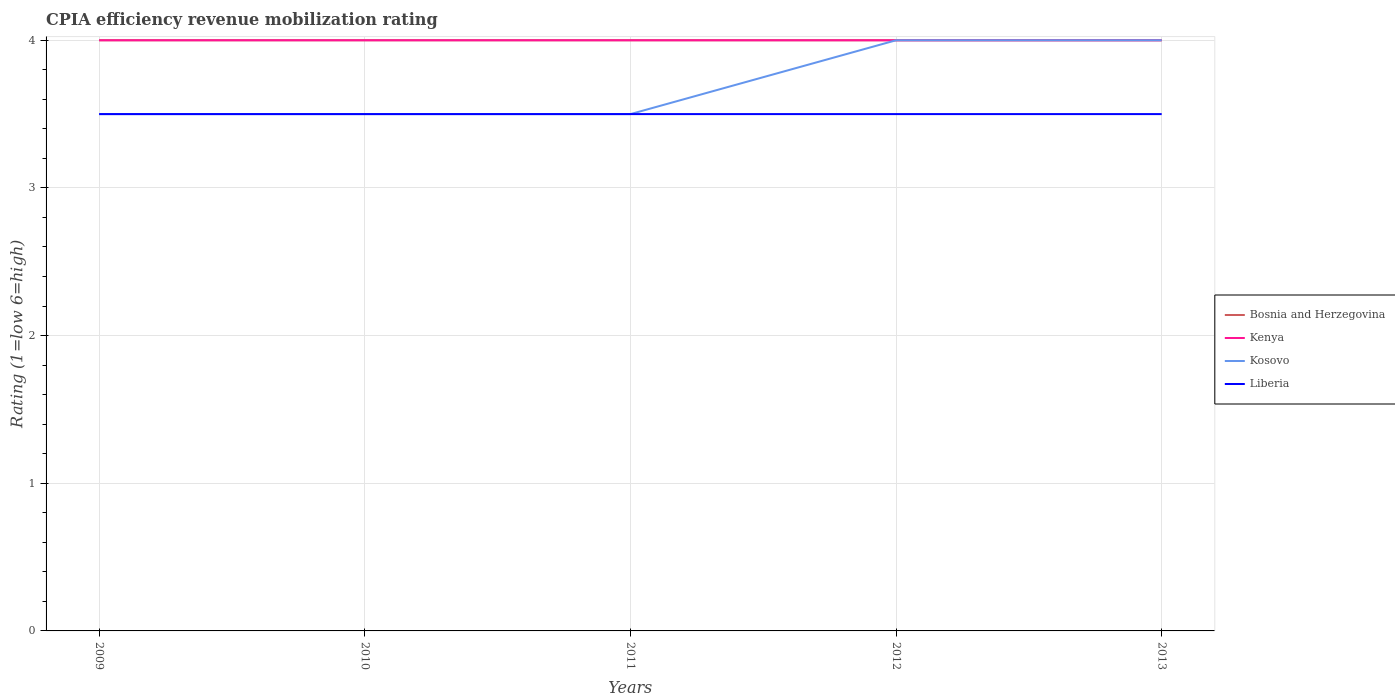How many different coloured lines are there?
Your response must be concise. 4. Is the number of lines equal to the number of legend labels?
Offer a very short reply. Yes. Across all years, what is the maximum CPIA rating in Kenya?
Provide a short and direct response. 4. In which year was the CPIA rating in Kosovo maximum?
Your answer should be compact. 2009. What is the total CPIA rating in Bosnia and Herzegovina in the graph?
Offer a terse response. 0. What is the difference between the highest and the lowest CPIA rating in Liberia?
Give a very brief answer. 0. Is the CPIA rating in Kenya strictly greater than the CPIA rating in Liberia over the years?
Make the answer very short. No. What is the difference between two consecutive major ticks on the Y-axis?
Offer a very short reply. 1. Are the values on the major ticks of Y-axis written in scientific E-notation?
Give a very brief answer. No. What is the title of the graph?
Provide a succinct answer. CPIA efficiency revenue mobilization rating. Does "Fragile and conflict affected situations" appear as one of the legend labels in the graph?
Provide a short and direct response. No. What is the label or title of the X-axis?
Offer a terse response. Years. What is the label or title of the Y-axis?
Your answer should be very brief. Rating (1=low 6=high). What is the Rating (1=low 6=high) of Kosovo in 2009?
Give a very brief answer. 3.5. What is the Rating (1=low 6=high) of Liberia in 2009?
Provide a short and direct response. 3.5. What is the Rating (1=low 6=high) of Bosnia and Herzegovina in 2010?
Your answer should be compact. 4. What is the Rating (1=low 6=high) of Liberia in 2010?
Provide a succinct answer. 3.5. What is the Rating (1=low 6=high) in Bosnia and Herzegovina in 2011?
Make the answer very short. 4. What is the Rating (1=low 6=high) in Liberia in 2011?
Your answer should be compact. 3.5. What is the Rating (1=low 6=high) of Bosnia and Herzegovina in 2012?
Offer a terse response. 4. What is the Rating (1=low 6=high) of Kenya in 2012?
Provide a succinct answer. 4. What is the Rating (1=low 6=high) of Liberia in 2012?
Your response must be concise. 3.5. What is the Rating (1=low 6=high) in Kosovo in 2013?
Give a very brief answer. 4. Across all years, what is the maximum Rating (1=low 6=high) of Kenya?
Give a very brief answer. 4. Across all years, what is the maximum Rating (1=low 6=high) of Liberia?
Your response must be concise. 3.5. Across all years, what is the minimum Rating (1=low 6=high) in Kenya?
Ensure brevity in your answer.  4. What is the total Rating (1=low 6=high) in Bosnia and Herzegovina in the graph?
Ensure brevity in your answer.  20. What is the total Rating (1=low 6=high) in Kenya in the graph?
Ensure brevity in your answer.  20. What is the total Rating (1=low 6=high) of Kosovo in the graph?
Offer a very short reply. 18.5. What is the difference between the Rating (1=low 6=high) of Kenya in 2009 and that in 2010?
Make the answer very short. 0. What is the difference between the Rating (1=low 6=high) in Kosovo in 2009 and that in 2010?
Make the answer very short. 0. What is the difference between the Rating (1=low 6=high) of Liberia in 2009 and that in 2010?
Your answer should be compact. 0. What is the difference between the Rating (1=low 6=high) of Kenya in 2009 and that in 2011?
Provide a short and direct response. 0. What is the difference between the Rating (1=low 6=high) of Liberia in 2009 and that in 2011?
Your answer should be compact. 0. What is the difference between the Rating (1=low 6=high) in Bosnia and Herzegovina in 2009 and that in 2012?
Provide a succinct answer. 0. What is the difference between the Rating (1=low 6=high) of Kosovo in 2009 and that in 2012?
Your response must be concise. -0.5. What is the difference between the Rating (1=low 6=high) in Liberia in 2009 and that in 2012?
Your answer should be compact. 0. What is the difference between the Rating (1=low 6=high) in Bosnia and Herzegovina in 2009 and that in 2013?
Your answer should be very brief. 0. What is the difference between the Rating (1=low 6=high) of Kosovo in 2009 and that in 2013?
Ensure brevity in your answer.  -0.5. What is the difference between the Rating (1=low 6=high) in Liberia in 2009 and that in 2013?
Ensure brevity in your answer.  0. What is the difference between the Rating (1=low 6=high) of Bosnia and Herzegovina in 2010 and that in 2011?
Give a very brief answer. 0. What is the difference between the Rating (1=low 6=high) of Kenya in 2010 and that in 2011?
Provide a short and direct response. 0. What is the difference between the Rating (1=low 6=high) in Kosovo in 2010 and that in 2011?
Your answer should be very brief. 0. What is the difference between the Rating (1=low 6=high) of Liberia in 2010 and that in 2011?
Give a very brief answer. 0. What is the difference between the Rating (1=low 6=high) in Liberia in 2010 and that in 2012?
Give a very brief answer. 0. What is the difference between the Rating (1=low 6=high) in Kosovo in 2010 and that in 2013?
Keep it short and to the point. -0.5. What is the difference between the Rating (1=low 6=high) of Bosnia and Herzegovina in 2011 and that in 2012?
Your response must be concise. 0. What is the difference between the Rating (1=low 6=high) of Liberia in 2011 and that in 2012?
Keep it short and to the point. 0. What is the difference between the Rating (1=low 6=high) in Bosnia and Herzegovina in 2011 and that in 2013?
Give a very brief answer. 0. What is the difference between the Rating (1=low 6=high) of Bosnia and Herzegovina in 2012 and that in 2013?
Provide a short and direct response. 0. What is the difference between the Rating (1=low 6=high) in Liberia in 2012 and that in 2013?
Offer a very short reply. 0. What is the difference between the Rating (1=low 6=high) in Bosnia and Herzegovina in 2009 and the Rating (1=low 6=high) in Kosovo in 2010?
Provide a short and direct response. 0.5. What is the difference between the Rating (1=low 6=high) in Kenya in 2009 and the Rating (1=low 6=high) in Kosovo in 2010?
Offer a very short reply. 0.5. What is the difference between the Rating (1=low 6=high) of Kenya in 2009 and the Rating (1=low 6=high) of Kosovo in 2011?
Give a very brief answer. 0.5. What is the difference between the Rating (1=low 6=high) of Kosovo in 2009 and the Rating (1=low 6=high) of Liberia in 2011?
Provide a short and direct response. 0. What is the difference between the Rating (1=low 6=high) of Bosnia and Herzegovina in 2009 and the Rating (1=low 6=high) of Kenya in 2012?
Offer a terse response. 0. What is the difference between the Rating (1=low 6=high) in Kosovo in 2009 and the Rating (1=low 6=high) in Liberia in 2012?
Provide a succinct answer. 0. What is the difference between the Rating (1=low 6=high) in Bosnia and Herzegovina in 2009 and the Rating (1=low 6=high) in Kenya in 2013?
Your answer should be compact. 0. What is the difference between the Rating (1=low 6=high) of Bosnia and Herzegovina in 2009 and the Rating (1=low 6=high) of Liberia in 2013?
Your response must be concise. 0.5. What is the difference between the Rating (1=low 6=high) in Kenya in 2009 and the Rating (1=low 6=high) in Kosovo in 2013?
Keep it short and to the point. 0. What is the difference between the Rating (1=low 6=high) of Kenya in 2010 and the Rating (1=low 6=high) of Kosovo in 2011?
Make the answer very short. 0.5. What is the difference between the Rating (1=low 6=high) of Kosovo in 2010 and the Rating (1=low 6=high) of Liberia in 2011?
Ensure brevity in your answer.  0. What is the difference between the Rating (1=low 6=high) of Kenya in 2010 and the Rating (1=low 6=high) of Kosovo in 2012?
Provide a short and direct response. 0. What is the difference between the Rating (1=low 6=high) in Kosovo in 2010 and the Rating (1=low 6=high) in Liberia in 2012?
Ensure brevity in your answer.  0. What is the difference between the Rating (1=low 6=high) of Bosnia and Herzegovina in 2010 and the Rating (1=low 6=high) of Kenya in 2013?
Your answer should be compact. 0. What is the difference between the Rating (1=low 6=high) of Bosnia and Herzegovina in 2010 and the Rating (1=low 6=high) of Liberia in 2013?
Make the answer very short. 0.5. What is the difference between the Rating (1=low 6=high) in Kenya in 2010 and the Rating (1=low 6=high) in Kosovo in 2013?
Offer a very short reply. 0. What is the difference between the Rating (1=low 6=high) in Bosnia and Herzegovina in 2011 and the Rating (1=low 6=high) in Kenya in 2012?
Your answer should be very brief. 0. What is the difference between the Rating (1=low 6=high) of Bosnia and Herzegovina in 2011 and the Rating (1=low 6=high) of Kosovo in 2012?
Offer a very short reply. 0. What is the difference between the Rating (1=low 6=high) of Bosnia and Herzegovina in 2011 and the Rating (1=low 6=high) of Liberia in 2012?
Keep it short and to the point. 0.5. What is the difference between the Rating (1=low 6=high) in Kenya in 2011 and the Rating (1=low 6=high) in Liberia in 2012?
Provide a short and direct response. 0.5. What is the difference between the Rating (1=low 6=high) in Bosnia and Herzegovina in 2011 and the Rating (1=low 6=high) in Kenya in 2013?
Keep it short and to the point. 0. What is the difference between the Rating (1=low 6=high) in Bosnia and Herzegovina in 2011 and the Rating (1=low 6=high) in Kosovo in 2013?
Your answer should be compact. 0. What is the difference between the Rating (1=low 6=high) in Bosnia and Herzegovina in 2011 and the Rating (1=low 6=high) in Liberia in 2013?
Your answer should be very brief. 0.5. What is the difference between the Rating (1=low 6=high) of Kenya in 2011 and the Rating (1=low 6=high) of Liberia in 2013?
Offer a terse response. 0.5. What is the difference between the Rating (1=low 6=high) in Bosnia and Herzegovina in 2012 and the Rating (1=low 6=high) in Kenya in 2013?
Ensure brevity in your answer.  0. What is the difference between the Rating (1=low 6=high) in Bosnia and Herzegovina in 2012 and the Rating (1=low 6=high) in Liberia in 2013?
Provide a short and direct response. 0.5. What is the difference between the Rating (1=low 6=high) of Kenya in 2012 and the Rating (1=low 6=high) of Kosovo in 2013?
Offer a terse response. 0. What is the difference between the Rating (1=low 6=high) in Kosovo in 2012 and the Rating (1=low 6=high) in Liberia in 2013?
Ensure brevity in your answer.  0.5. What is the average Rating (1=low 6=high) of Kosovo per year?
Make the answer very short. 3.7. What is the average Rating (1=low 6=high) in Liberia per year?
Give a very brief answer. 3.5. In the year 2009, what is the difference between the Rating (1=low 6=high) of Bosnia and Herzegovina and Rating (1=low 6=high) of Kenya?
Keep it short and to the point. 0. In the year 2009, what is the difference between the Rating (1=low 6=high) of Bosnia and Herzegovina and Rating (1=low 6=high) of Liberia?
Offer a very short reply. 0.5. In the year 2009, what is the difference between the Rating (1=low 6=high) in Kenya and Rating (1=low 6=high) in Liberia?
Offer a very short reply. 0.5. In the year 2009, what is the difference between the Rating (1=low 6=high) of Kosovo and Rating (1=low 6=high) of Liberia?
Your answer should be compact. 0. In the year 2010, what is the difference between the Rating (1=low 6=high) in Bosnia and Herzegovina and Rating (1=low 6=high) in Kosovo?
Keep it short and to the point. 0.5. In the year 2010, what is the difference between the Rating (1=low 6=high) in Bosnia and Herzegovina and Rating (1=low 6=high) in Liberia?
Make the answer very short. 0.5. In the year 2010, what is the difference between the Rating (1=low 6=high) in Kenya and Rating (1=low 6=high) in Liberia?
Your answer should be very brief. 0.5. In the year 2011, what is the difference between the Rating (1=low 6=high) in Bosnia and Herzegovina and Rating (1=low 6=high) in Kenya?
Keep it short and to the point. 0. In the year 2011, what is the difference between the Rating (1=low 6=high) in Bosnia and Herzegovina and Rating (1=low 6=high) in Kosovo?
Make the answer very short. 0.5. In the year 2011, what is the difference between the Rating (1=low 6=high) of Bosnia and Herzegovina and Rating (1=low 6=high) of Liberia?
Keep it short and to the point. 0.5. In the year 2011, what is the difference between the Rating (1=low 6=high) in Kosovo and Rating (1=low 6=high) in Liberia?
Offer a very short reply. 0. In the year 2012, what is the difference between the Rating (1=low 6=high) of Bosnia and Herzegovina and Rating (1=low 6=high) of Kenya?
Offer a terse response. 0. In the year 2012, what is the difference between the Rating (1=low 6=high) of Bosnia and Herzegovina and Rating (1=low 6=high) of Kosovo?
Your answer should be compact. 0. In the year 2012, what is the difference between the Rating (1=low 6=high) in Kenya and Rating (1=low 6=high) in Liberia?
Give a very brief answer. 0.5. In the year 2013, what is the difference between the Rating (1=low 6=high) in Kenya and Rating (1=low 6=high) in Liberia?
Give a very brief answer. 0.5. In the year 2013, what is the difference between the Rating (1=low 6=high) of Kosovo and Rating (1=low 6=high) of Liberia?
Keep it short and to the point. 0.5. What is the ratio of the Rating (1=low 6=high) of Bosnia and Herzegovina in 2009 to that in 2010?
Ensure brevity in your answer.  1. What is the ratio of the Rating (1=low 6=high) of Kenya in 2009 to that in 2010?
Offer a terse response. 1. What is the ratio of the Rating (1=low 6=high) in Liberia in 2009 to that in 2010?
Provide a short and direct response. 1. What is the ratio of the Rating (1=low 6=high) of Bosnia and Herzegovina in 2009 to that in 2011?
Ensure brevity in your answer.  1. What is the ratio of the Rating (1=low 6=high) of Kosovo in 2009 to that in 2011?
Your answer should be compact. 1. What is the ratio of the Rating (1=low 6=high) in Liberia in 2009 to that in 2011?
Your answer should be compact. 1. What is the ratio of the Rating (1=low 6=high) in Bosnia and Herzegovina in 2009 to that in 2012?
Your answer should be very brief. 1. What is the ratio of the Rating (1=low 6=high) in Liberia in 2009 to that in 2012?
Keep it short and to the point. 1. What is the ratio of the Rating (1=low 6=high) of Kenya in 2009 to that in 2013?
Keep it short and to the point. 1. What is the ratio of the Rating (1=low 6=high) of Liberia in 2009 to that in 2013?
Make the answer very short. 1. What is the ratio of the Rating (1=low 6=high) in Kosovo in 2010 to that in 2012?
Offer a terse response. 0.88. What is the ratio of the Rating (1=low 6=high) in Bosnia and Herzegovina in 2010 to that in 2013?
Your answer should be very brief. 1. What is the ratio of the Rating (1=low 6=high) in Kenya in 2010 to that in 2013?
Offer a terse response. 1. What is the ratio of the Rating (1=low 6=high) in Kosovo in 2010 to that in 2013?
Ensure brevity in your answer.  0.88. What is the ratio of the Rating (1=low 6=high) in Liberia in 2010 to that in 2013?
Ensure brevity in your answer.  1. What is the ratio of the Rating (1=low 6=high) in Bosnia and Herzegovina in 2011 to that in 2012?
Offer a terse response. 1. What is the ratio of the Rating (1=low 6=high) of Kenya in 2011 to that in 2012?
Your answer should be compact. 1. What is the ratio of the Rating (1=low 6=high) of Liberia in 2011 to that in 2012?
Your answer should be compact. 1. What is the ratio of the Rating (1=low 6=high) of Kosovo in 2011 to that in 2013?
Your response must be concise. 0.88. What is the ratio of the Rating (1=low 6=high) of Liberia in 2011 to that in 2013?
Your response must be concise. 1. What is the ratio of the Rating (1=low 6=high) of Bosnia and Herzegovina in 2012 to that in 2013?
Provide a succinct answer. 1. What is the ratio of the Rating (1=low 6=high) in Liberia in 2012 to that in 2013?
Offer a terse response. 1. What is the difference between the highest and the second highest Rating (1=low 6=high) in Bosnia and Herzegovina?
Ensure brevity in your answer.  0. What is the difference between the highest and the second highest Rating (1=low 6=high) of Kenya?
Provide a succinct answer. 0. What is the difference between the highest and the second highest Rating (1=low 6=high) in Liberia?
Offer a terse response. 0. What is the difference between the highest and the lowest Rating (1=low 6=high) in Kosovo?
Provide a succinct answer. 0.5. 